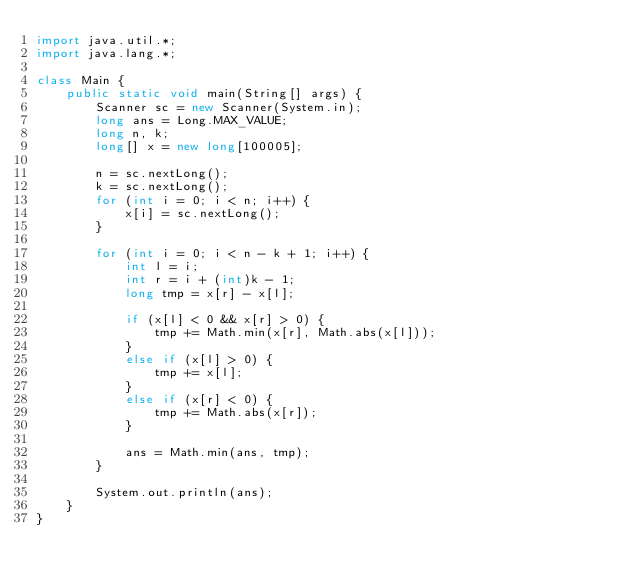<code> <loc_0><loc_0><loc_500><loc_500><_Java_>import java.util.*;
import java.lang.*;

class Main {
    public static void main(String[] args) {
        Scanner sc = new Scanner(System.in);
        long ans = Long.MAX_VALUE;
        long n, k;
        long[] x = new long[100005];

        n = sc.nextLong();
        k = sc.nextLong();
        for (int i = 0; i < n; i++) {
            x[i] = sc.nextLong();
        }

        for (int i = 0; i < n - k + 1; i++) {
            int l = i;
            int r = i + (int)k - 1;
            long tmp = x[r] - x[l];

            if (x[l] < 0 && x[r] > 0) {
                tmp += Math.min(x[r], Math.abs(x[l]));
            }
            else if (x[l] > 0) {
                tmp += x[l];
            }
            else if (x[r] < 0) {
                tmp += Math.abs(x[r]);
            }

            ans = Math.min(ans, tmp);
        }

        System.out.println(ans);
    }
}
</code> 